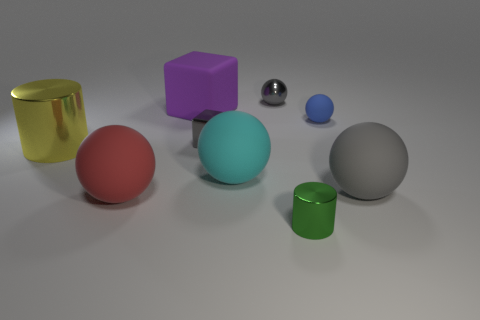What number of metallic things are the same color as the tiny metallic block? There is one metallic sphere that is the same color - silver - as the tiny metallic block. 